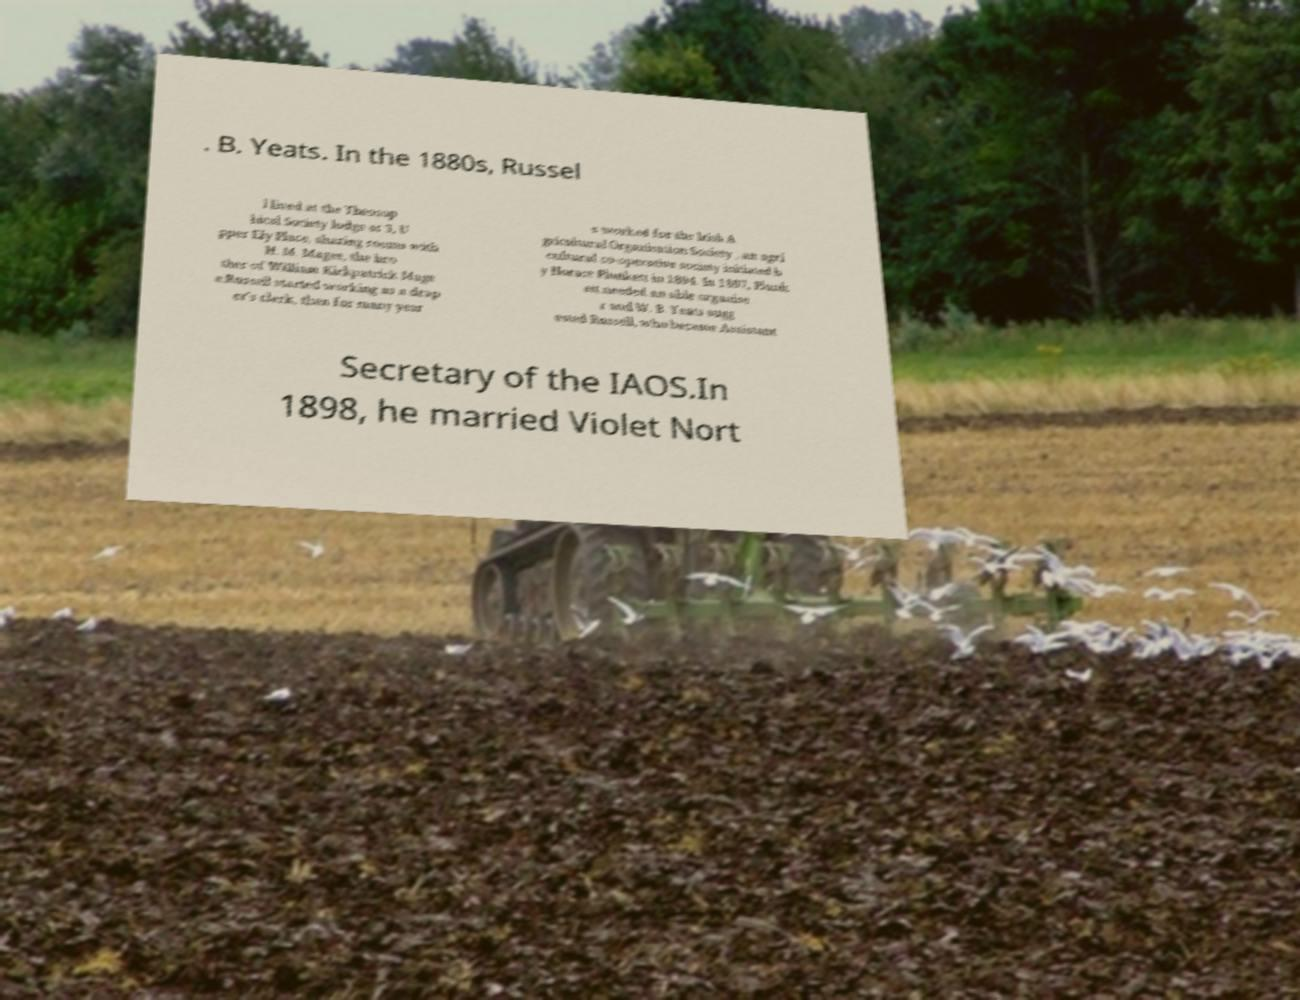For documentation purposes, I need the text within this image transcribed. Could you provide that? . B. Yeats. In the 1880s, Russel l lived at the Theosop hical Society lodge at 3, U pper Ely Place, sharing rooms with H. M. Magee, the bro ther of William Kirkpatrick Mage e.Russell started working as a drap er's clerk, then for many year s worked for the Irish A gricultural Organisation Society , an agri cultural co-operative society initiated b y Horace Plunkett in 1894. In 1897, Plunk ett needed an able organise r and W. B. Yeats sugg ested Russell, who became Assistant Secretary of the IAOS.In 1898, he married Violet Nort 